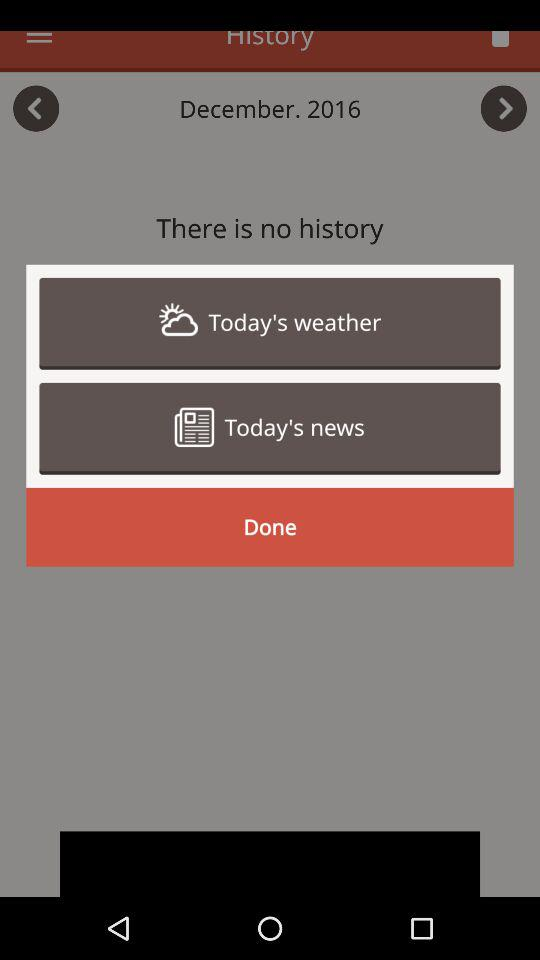What is the selected month and year? The selected month and year are December and 2016. 